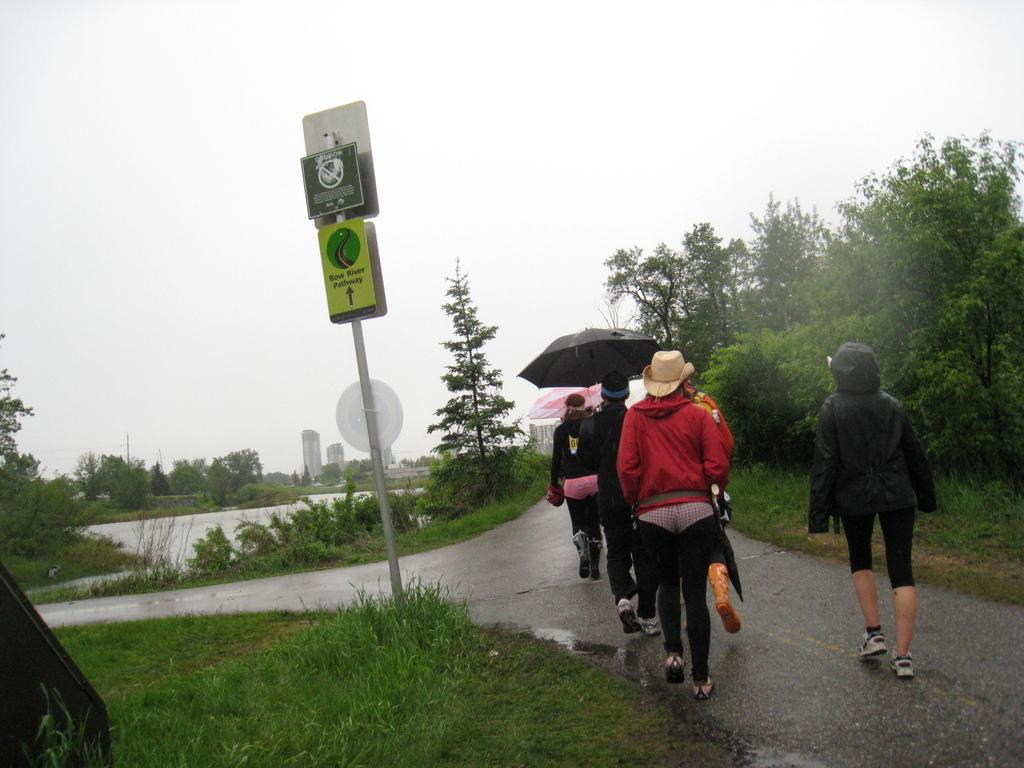What are the people in the image doing? The people in the image are walking on the road. What are the people using to protect themselves from the weather? The people are holding umbrellas. What type of vegetation is visible near the road? There are trees beside the road. What body of water can be seen in the image? There is a lake visible in the image. What structure is present with boards attached to it? There is a pole with boards in the image. What is the opinion of the lake about the people walking on the road? The lake does not have an opinion, as it is an inanimate object and cannot express thoughts or feelings. What type of smell can be detected from the image? The image does not provide any information about smells, so it cannot be determined from the image. 